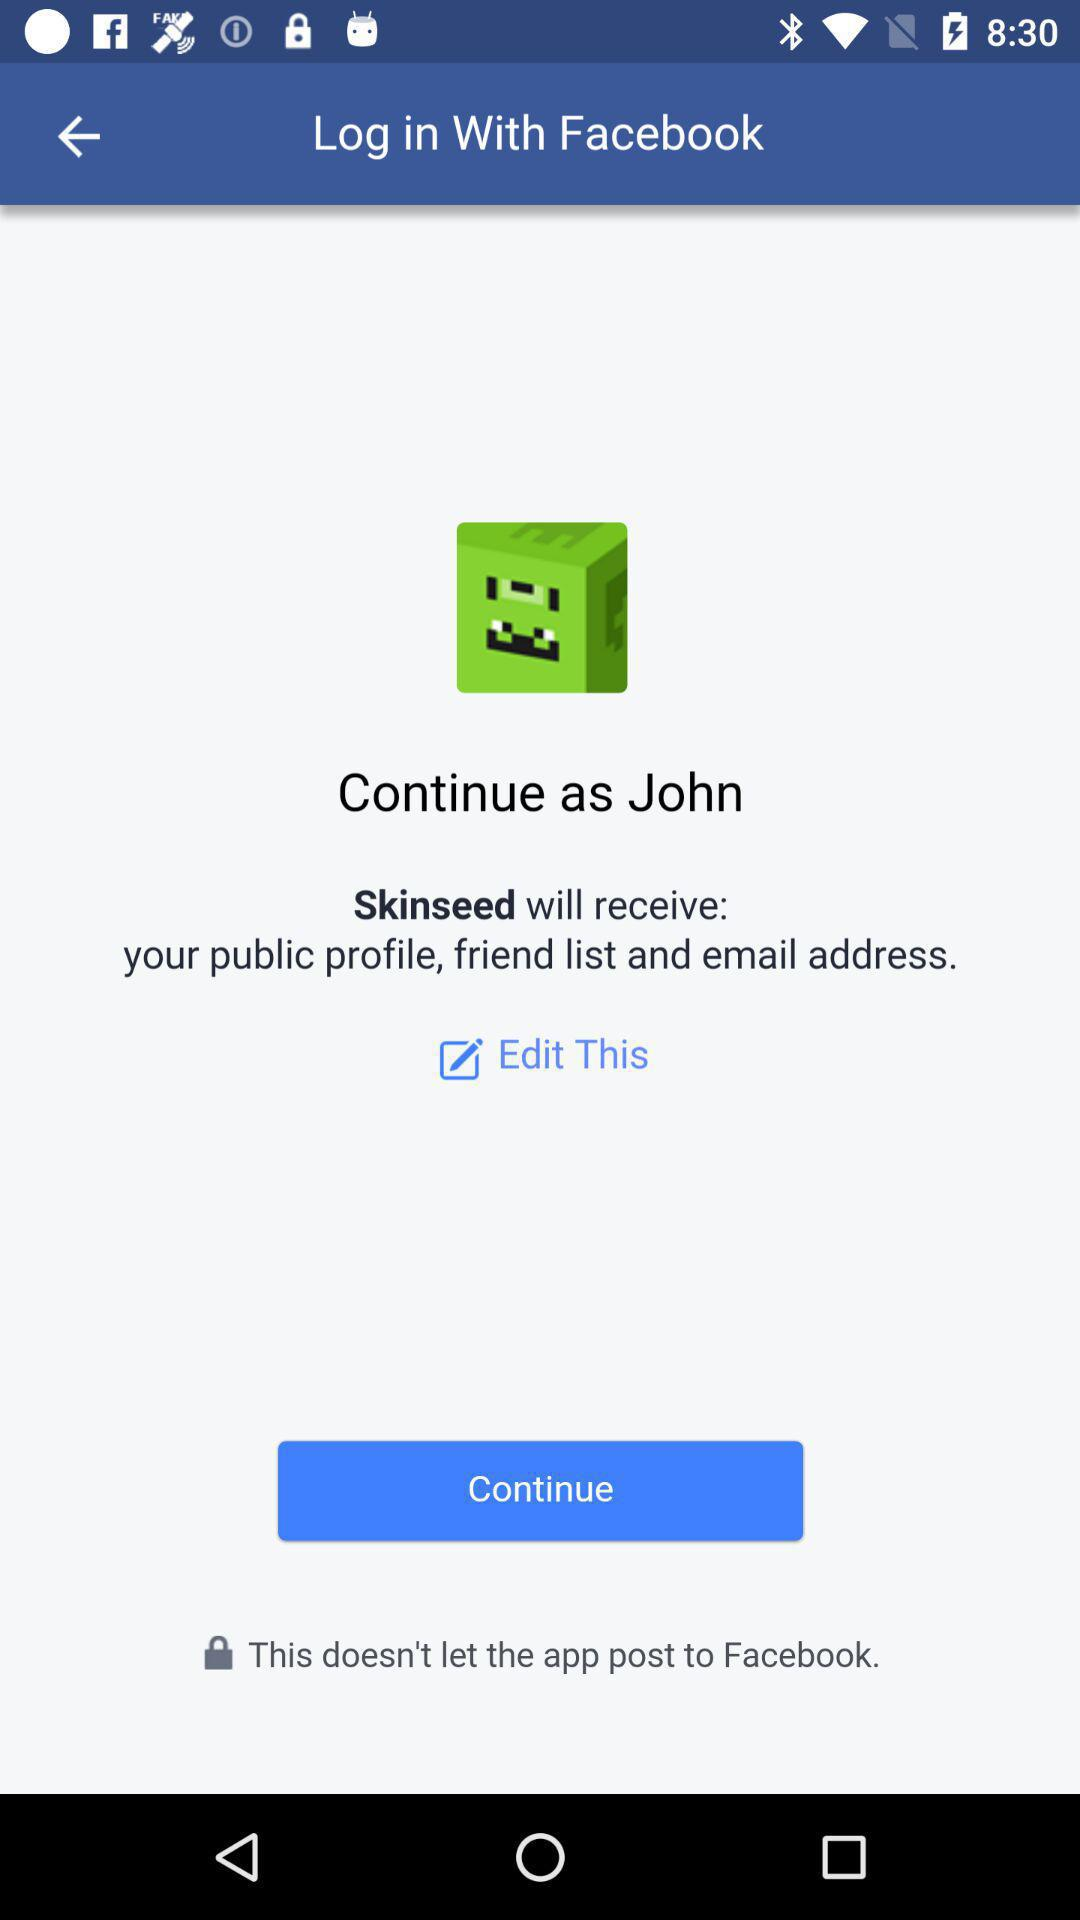What application can be used to log in? The application that can be used to log in is "Facebook". 